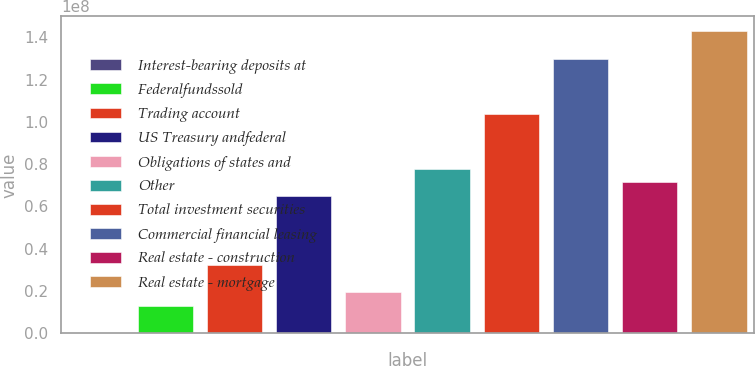<chart> <loc_0><loc_0><loc_500><loc_500><bar_chart><fcel>Interest-bearing deposits at<fcel>Federalfundssold<fcel>Trading account<fcel>US Treasury andfederal<fcel>Obligations of states and<fcel>Other<fcel>Total investment securities<fcel>Commercial financial leasing<fcel>Real estate - construction<fcel>Real estate - mortgage<nl><fcel>18431<fcel>1.29899e+07<fcel>3.2447e+07<fcel>6.48756e+07<fcel>1.94756e+07<fcel>7.78471e+07<fcel>1.0379e+08<fcel>1.29733e+08<fcel>7.13614e+07<fcel>1.42704e+08<nl></chart> 